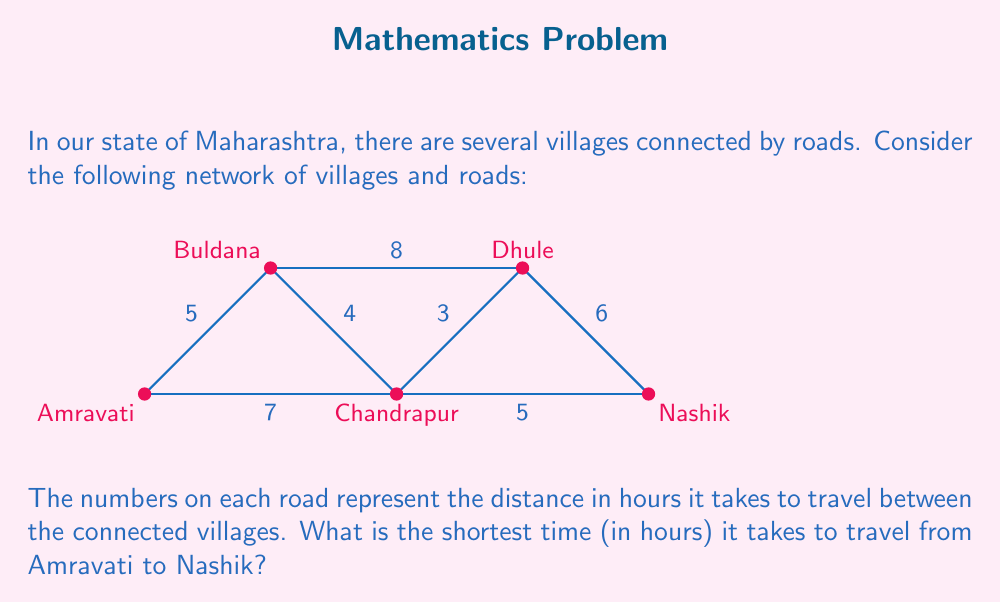What is the answer to this math problem? To find the shortest path from Amravati to Nashik, we can use Dijkstra's algorithm. However, for this simple network, we can also solve it by considering all possible paths:

1. Amravati → Buldana → Chandrapur → Dhule → Nashik
   Time = $5 + 4 + 3 + 6 = 18$ hours

2. Amravati → Buldana → Dhule → Nashik
   Time = $5 + 8 + 6 = 19$ hours

3. Amravati → Chandrapur → Dhule → Nashik
   Time = $7 + 3 + 6 = 16$ hours

4. Amravati → Chandrapur → Nashik
   Time = $7 + 5 = 12$ hours

The shortest path is Amravati → Chandrapur → Nashik, which takes 12 hours.

To verify this is indeed the shortest path, we can check that no other combination of roads can give a shorter time:

- Going through Buldana always adds unnecessary time.
- Going through Dhule adds at least 3 + 6 = 9 hours, which is already longer than the direct Chandrapur → Nashik route of 5 hours.

Therefore, the shortest path is Amravati → Chandrapur → Nashik, with a total travel time of 12 hours.
Answer: 12 hours 